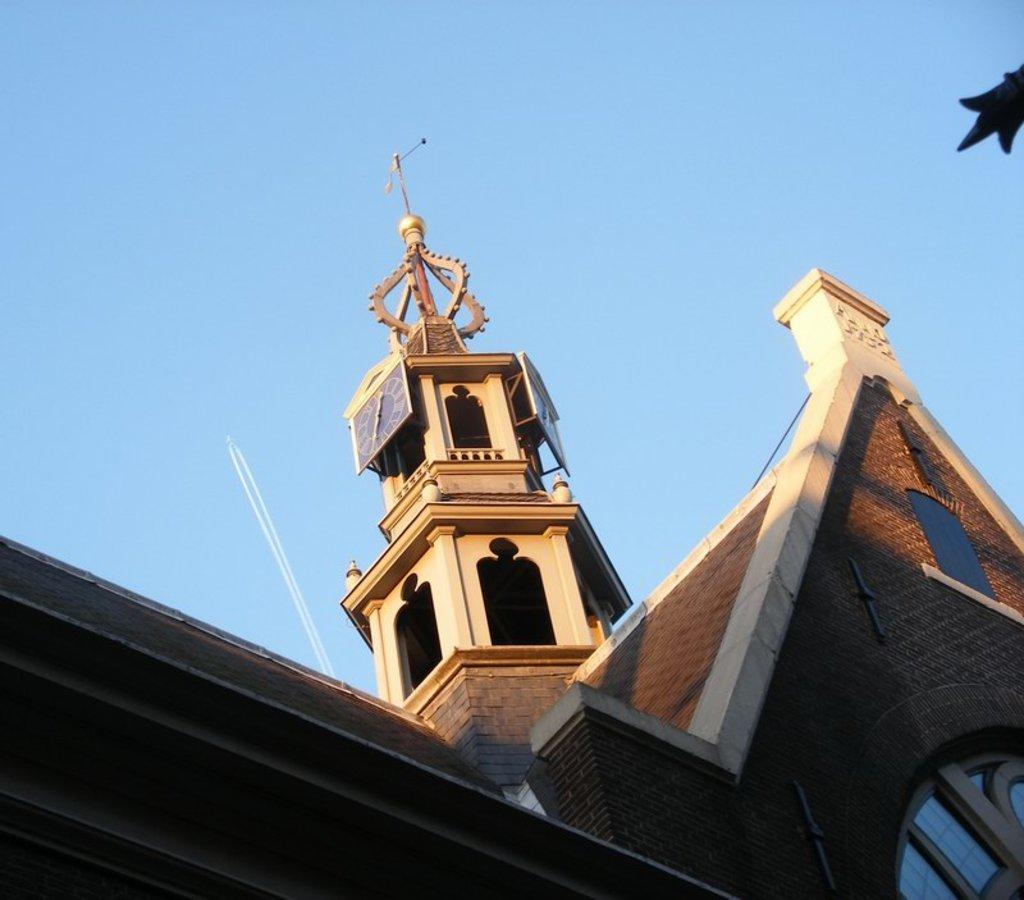What type of view is shown in the image? The image is an outside view. What structures can be seen in the image? There is a building and a tower in the image. What is visible at the top of the image? The sky is visible at the top of the image. What sound can be heard coming from the tower in the image? There is no information about any sound coming from the tower in the image. 